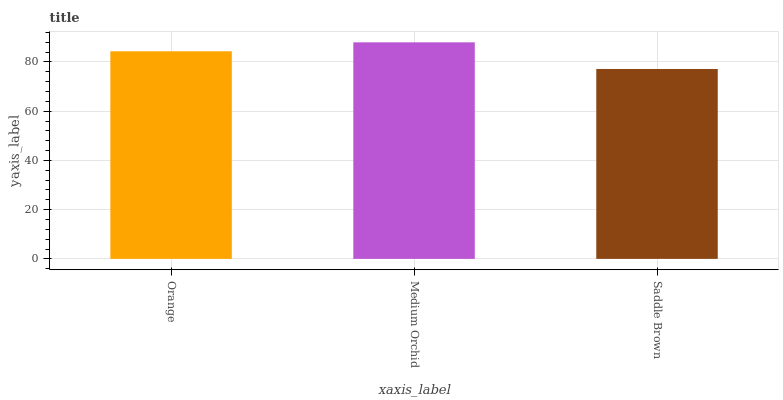Is Saddle Brown the minimum?
Answer yes or no. Yes. Is Medium Orchid the maximum?
Answer yes or no. Yes. Is Medium Orchid the minimum?
Answer yes or no. No. Is Saddle Brown the maximum?
Answer yes or no. No. Is Medium Orchid greater than Saddle Brown?
Answer yes or no. Yes. Is Saddle Brown less than Medium Orchid?
Answer yes or no. Yes. Is Saddle Brown greater than Medium Orchid?
Answer yes or no. No. Is Medium Orchid less than Saddle Brown?
Answer yes or no. No. Is Orange the high median?
Answer yes or no. Yes. Is Orange the low median?
Answer yes or no. Yes. Is Saddle Brown the high median?
Answer yes or no. No. Is Medium Orchid the low median?
Answer yes or no. No. 